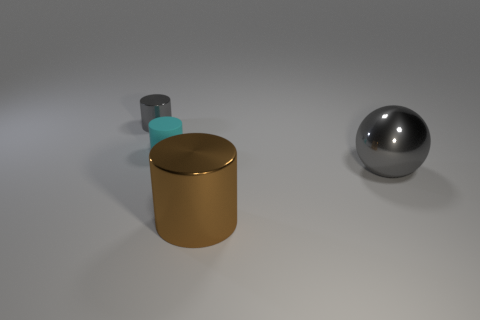There is a sphere that is the same color as the small metal cylinder; what is it made of?
Offer a very short reply. Metal. What shape is the metal object that is the same color as the large sphere?
Provide a short and direct response. Cylinder. There is another object that is the same color as the small shiny thing; what size is it?
Offer a very short reply. Large. There is a small cylinder on the right side of the metallic thing to the left of the tiny cyan matte cylinder; what is its color?
Keep it short and to the point. Cyan. How many other things are the same color as the large ball?
Your answer should be compact. 1. What is the size of the shiny ball?
Give a very brief answer. Large. Is the number of tiny metal cylinders right of the big brown object greater than the number of small rubber cylinders behind the rubber thing?
Keep it short and to the point. No. There is a cyan object on the left side of the large gray metal sphere; what number of small things are behind it?
Your response must be concise. 1. Does the large object that is to the right of the big brown metal cylinder have the same shape as the tiny gray metallic thing?
Your response must be concise. No. There is another tiny thing that is the same shape as the tiny rubber object; what is its material?
Your response must be concise. Metal. 